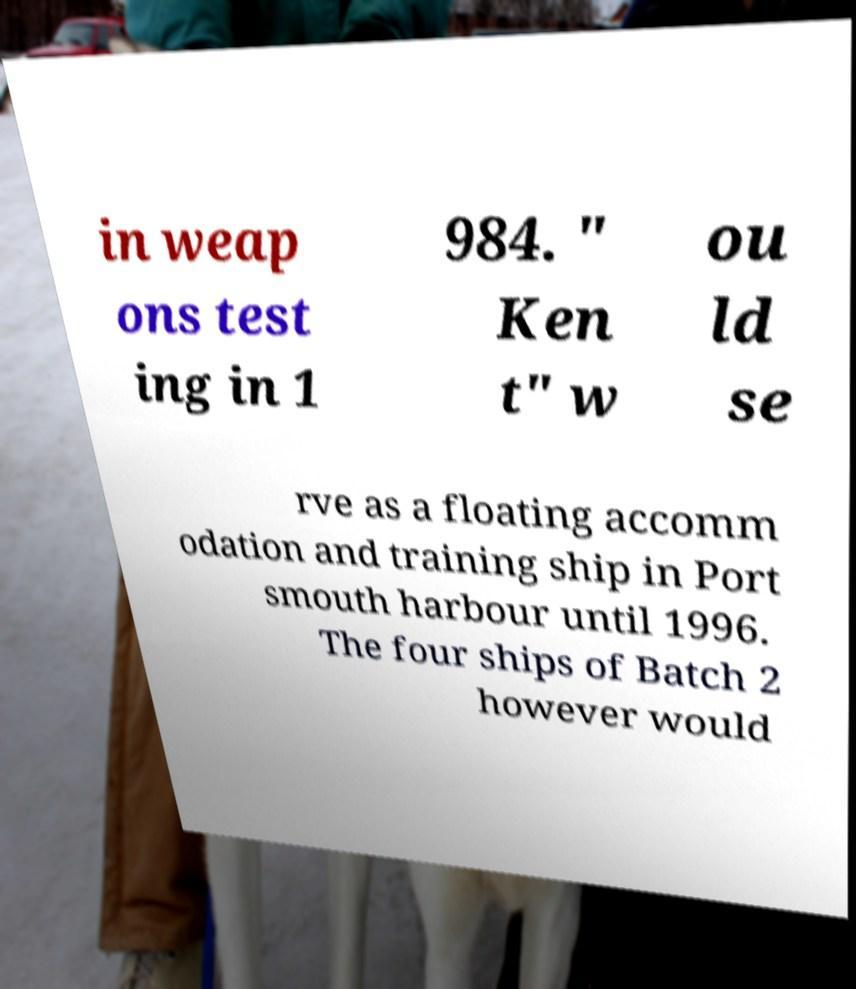There's text embedded in this image that I need extracted. Can you transcribe it verbatim? in weap ons test ing in 1 984. " Ken t" w ou ld se rve as a floating accomm odation and training ship in Port smouth harbour until 1996. The four ships of Batch 2 however would 